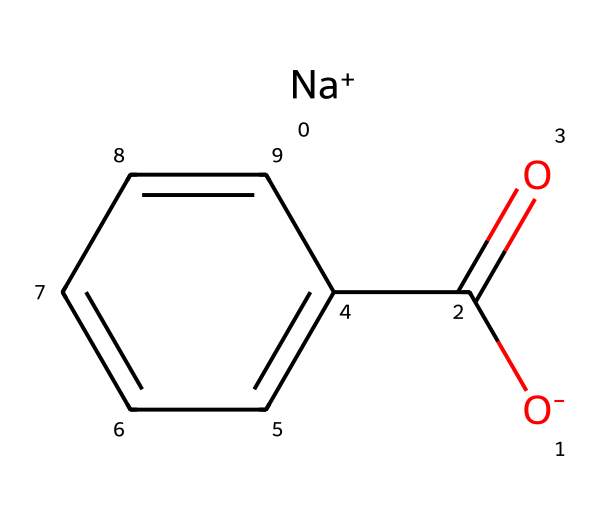What is the molecular formula of sodium benzoate? The molecular formula can be derived from the structure. It consists of one sodium (Na) atom, one carbon (C) atom from the carboxyl group, and seven carbon (C) atoms from the benzene ring, leading to a total of eight carbon atoms. Additionally, there are five hydrogen (H) atoms and two oxygen (O) atoms. Thus, the complete molecular formula is C7H5NaO2.
Answer: C7H5NaO2 How many oxygen atoms are present in sodium benzoate? The structure reveals there are two oxygen atoms: one in the carboxyl group and one attached to the sodium ion. Therefore, the total count is two oxygen atoms.
Answer: 2 Is sodium benzoate ionic or covalent? Looking at the presence of the sodium ion (Na+) and the negatively charged benzoate ion (C6H5COO-), we observe that sodium benzoate consists of an ionic bond between these two ions. Therefore, it is classified as ionic.
Answer: ionic What type of functional group is present in sodium benzoate? The structure indicates the presence of a carboxylic acid functional group (–COO–). This is identified by the presence of the carbonyl (C=O) and hydroxyl (–O) parts.
Answer: carboxylic acid How many carbon atoms are in the benzene ring of sodium benzoate? Within the structure, the benzene ring is composed of six carbon atoms arranged in a cyclic form. However, since one carbon is also part of the carboxylic group, a total of six carbon atoms belong to the benzene part of sodium benzoate.
Answer: 6 What is the charge of sodium in sodium benzoate? The structure shows sodium as Na+, indicating that it possesses a positive charge due to the loss of one electron. Therefore, the charge is positive.
Answer: positive Does sodium benzoate have preservative properties? Sodium benzoate has been widely recognized for its effectiveness as a preservative due to its ability to inhibit the growth of bacteria and fungi in acidic conditions, which are often found in packaged foods.
Answer: yes 